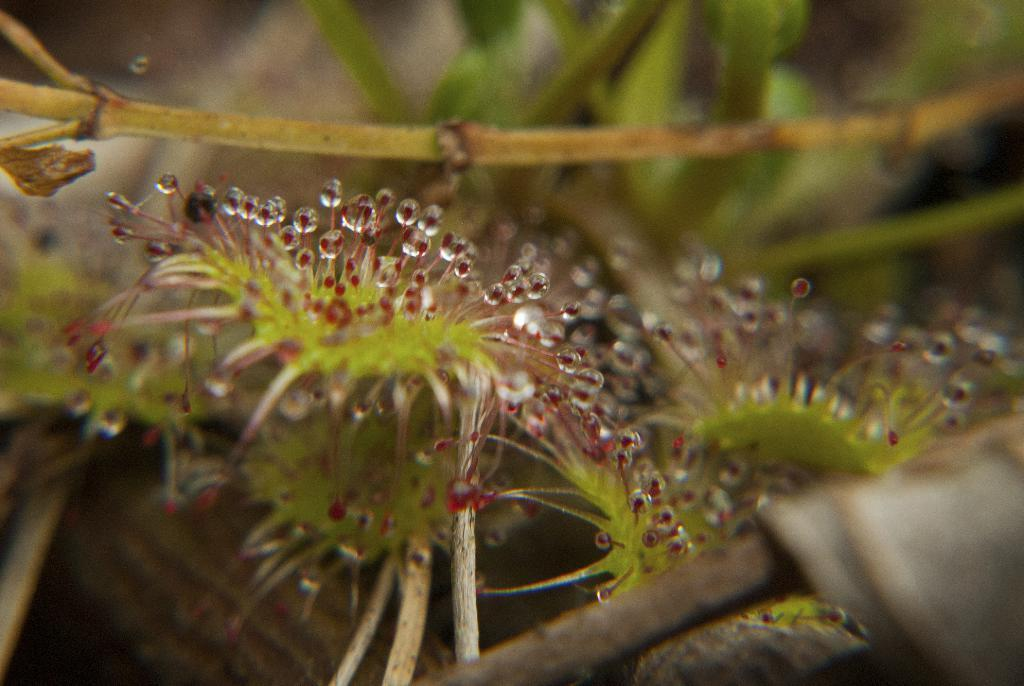What type of vegetation can be seen in the image? There are leaves in the image. What did your friend say to you during the morning while taking a bite of the leaf in the image? There is no friend, morning, or conversation present in the image; it only contains leaves. 